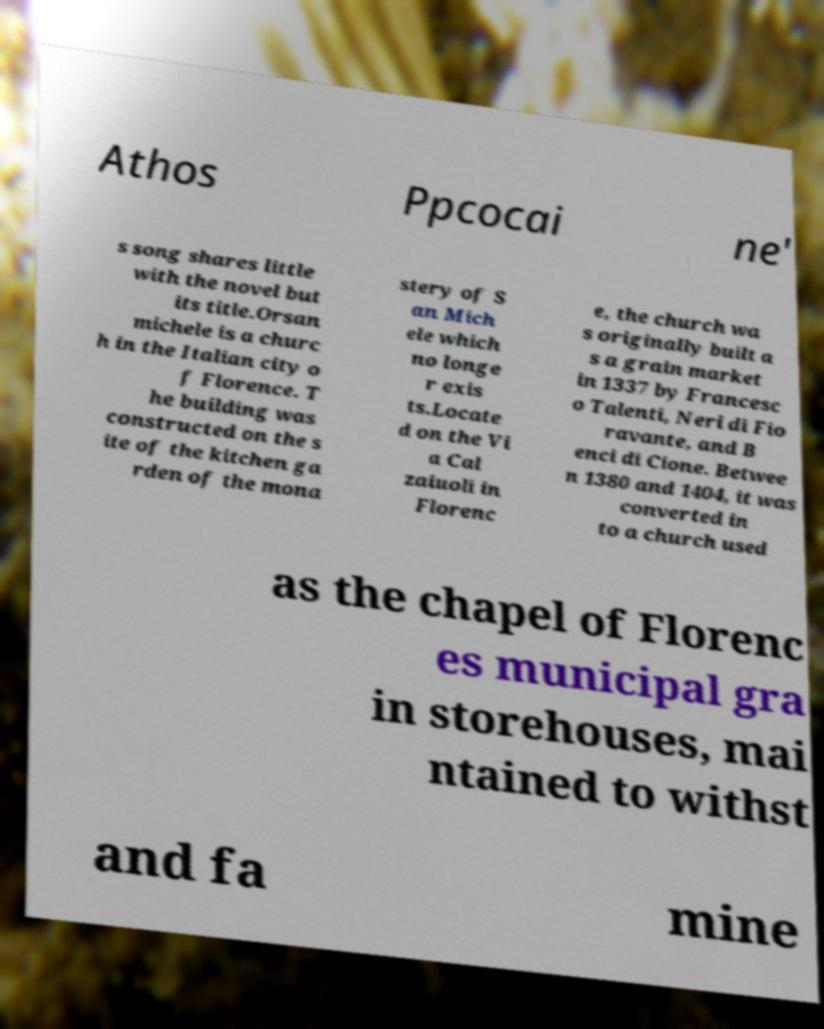Please read and relay the text visible in this image. What does it say? Athos Ppcocai ne' s song shares little with the novel but its title.Orsan michele is a churc h in the Italian city o f Florence. T he building was constructed on the s ite of the kitchen ga rden of the mona stery of S an Mich ele which no longe r exis ts.Locate d on the Vi a Cal zaiuoli in Florenc e, the church wa s originally built a s a grain market in 1337 by Francesc o Talenti, Neri di Fio ravante, and B enci di Cione. Betwee n 1380 and 1404, it was converted in to a church used as the chapel of Florenc es municipal gra in storehouses, mai ntained to withst and fa mine 